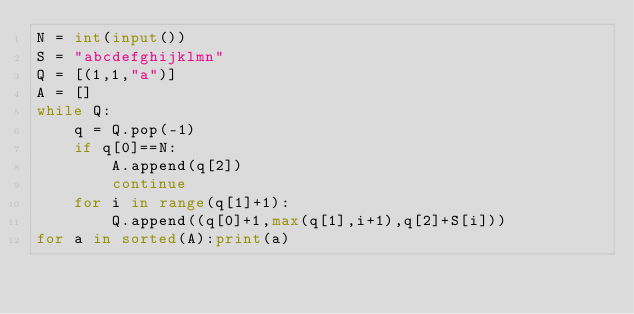<code> <loc_0><loc_0><loc_500><loc_500><_Python_>N = int(input())
S = "abcdefghijklmn"
Q = [(1,1,"a")]
A = []
while Q:
    q = Q.pop(-1)
    if q[0]==N:
        A.append(q[2])
        continue
    for i in range(q[1]+1):
        Q.append((q[0]+1,max(q[1],i+1),q[2]+S[i]))
for a in sorted(A):print(a)</code> 